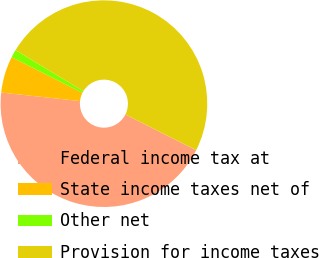Convert chart to OTSL. <chart><loc_0><loc_0><loc_500><loc_500><pie_chart><fcel>Federal income tax at<fcel>State income taxes net of<fcel>Other net<fcel>Provision for income taxes<nl><fcel>44.29%<fcel>5.71%<fcel>1.25%<fcel>48.75%<nl></chart> 